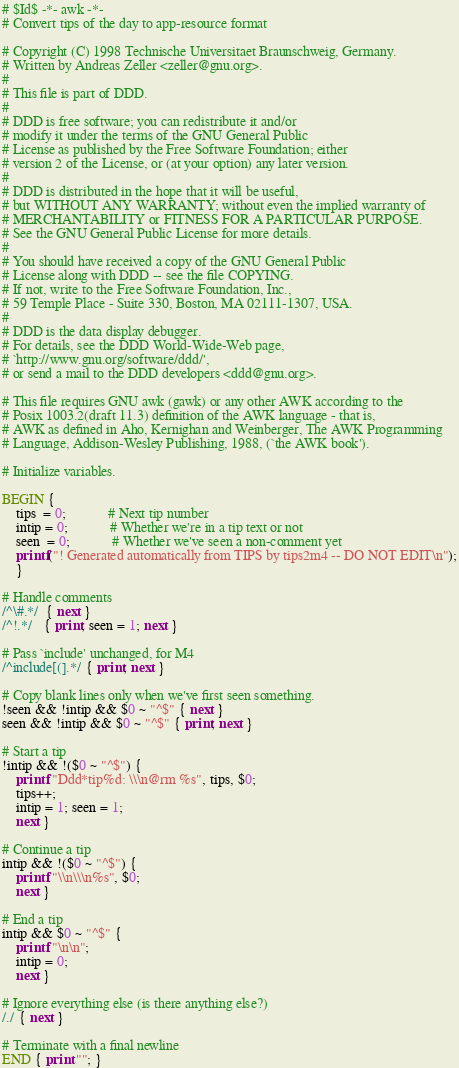<code> <loc_0><loc_0><loc_500><loc_500><_Awk_># $Id$ -*- awk -*-
# Convert tips of the day to app-resource format

# Copyright (C) 1998 Technische Universitaet Braunschweig, Germany.
# Written by Andreas Zeller <zeller@gnu.org>.
# 
# This file is part of DDD.
# 
# DDD is free software; you can redistribute it and/or
# modify it under the terms of the GNU General Public
# License as published by the Free Software Foundation; either
# version 2 of the License, or (at your option) any later version.
# 
# DDD is distributed in the hope that it will be useful,
# but WITHOUT ANY WARRANTY; without even the implied warranty of
# MERCHANTABILITY or FITNESS FOR A PARTICULAR PURPOSE.
# See the GNU General Public License for more details.
# 
# You should have received a copy of the GNU General Public
# License along with DDD -- see the file COPYING.
# If not, write to the Free Software Foundation, Inc.,
# 59 Temple Place - Suite 330, Boston, MA 02111-1307, USA.
# 
# DDD is the data display debugger.
# For details, see the DDD World-Wide-Web page, 
# `http://www.gnu.org/software/ddd/',
# or send a mail to the DDD developers <ddd@gnu.org>.

# This file requires GNU awk (gawk) or any other AWK according to the
# Posix 1003.2(draft 11.3) definition of the AWK language - that is,
# AWK as defined in Aho, Kernighan and Weinberger, The AWK Programming
# Language, Addison-Wesley Publishing, 1988, (`the AWK book').

# Initialize variables.

BEGIN { 
    tips  = 0;			# Next tip number
    intip = 0;			# Whether we're in a tip text or not
    seen  = 0;			# Whether we've seen a non-comment yet
    printf("! Generated automatically from TIPS by tips2m4 -- DO NOT EDIT\n");
    }

# Handle comments
/^\#.*/  { next }
/^!.*/   { print; seen = 1; next }

# Pass `include' unchanged, for M4
/^include[(].*/ { print; next }

# Copy blank lines only when we've first seen something.
!seen && !intip && $0 ~ "^$" { next }
seen && !intip && $0 ~ "^$" { print; next }

# Start a tip
!intip && !($0 ~ "^$") {
    printf "Ddd*tip%d: \\\n@rm %s", tips, $0;
    tips++;
    intip = 1; seen = 1;
    next }

# Continue a tip
intip && !($0 ~ "^$") {
    printf "\\n\\\n%s", $0;
    next }

# End a tip
intip && $0 ~ "^$" {
    printf "\n\n";
    intip = 0;
    next }

# Ignore everything else (is there anything else?)
/./ { next }

# Terminate with a final newline
END { print ""; }
</code> 